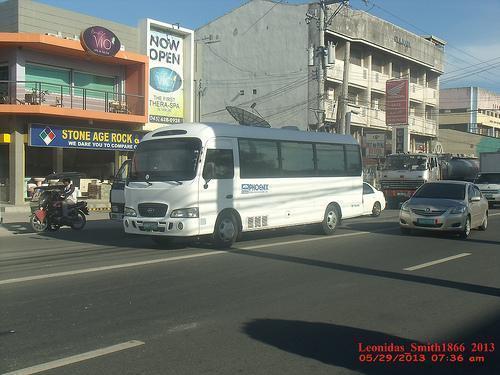How many buses are shown?
Give a very brief answer. 1. 